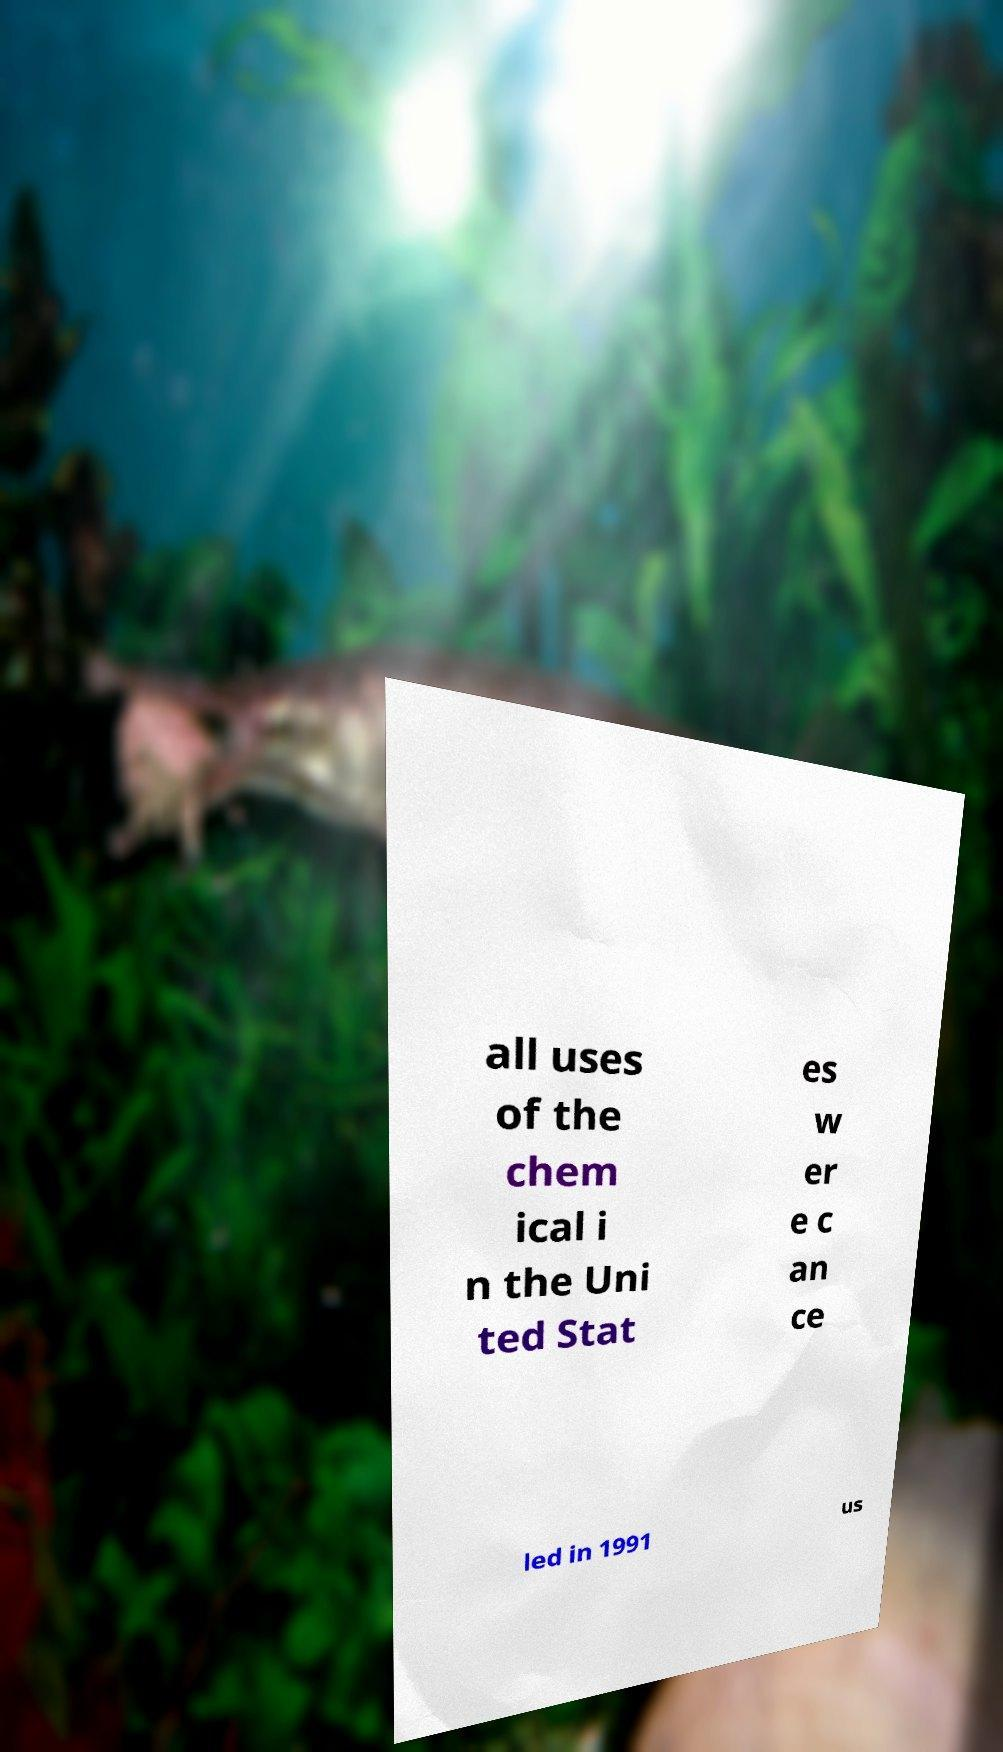Could you extract and type out the text from this image? all uses of the chem ical i n the Uni ted Stat es w er e c an ce led in 1991 us 